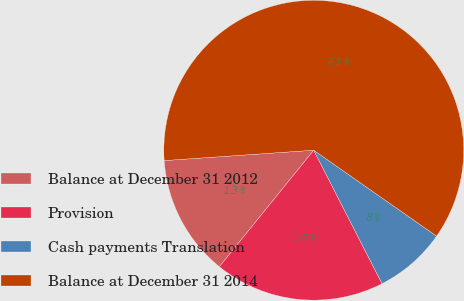Convert chart. <chart><loc_0><loc_0><loc_500><loc_500><pie_chart><fcel>Balance at December 31 2012<fcel>Provision<fcel>Cash payments Translation<fcel>Balance at December 31 2014<nl><fcel>13.06%<fcel>18.37%<fcel>7.76%<fcel>60.81%<nl></chart> 